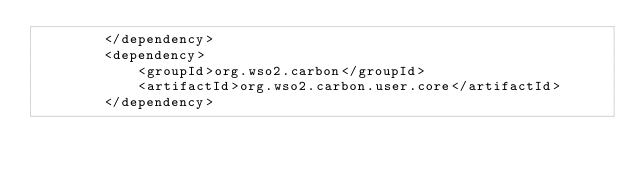Convert code to text. <code><loc_0><loc_0><loc_500><loc_500><_XML_>        </dependency>
        <dependency>
            <groupId>org.wso2.carbon</groupId>
            <artifactId>org.wso2.carbon.user.core</artifactId>
        </dependency></code> 